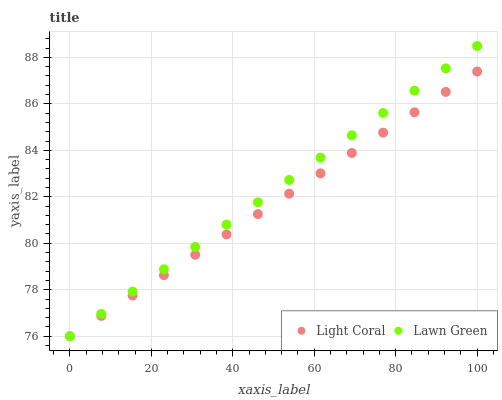Does Light Coral have the minimum area under the curve?
Answer yes or no. Yes. Does Lawn Green have the maximum area under the curve?
Answer yes or no. Yes. Does Lawn Green have the minimum area under the curve?
Answer yes or no. No. Is Light Coral the smoothest?
Answer yes or no. Yes. Is Lawn Green the roughest?
Answer yes or no. Yes. Is Lawn Green the smoothest?
Answer yes or no. No. Does Light Coral have the lowest value?
Answer yes or no. Yes. Does Lawn Green have the highest value?
Answer yes or no. Yes. Does Light Coral intersect Lawn Green?
Answer yes or no. Yes. Is Light Coral less than Lawn Green?
Answer yes or no. No. Is Light Coral greater than Lawn Green?
Answer yes or no. No. 